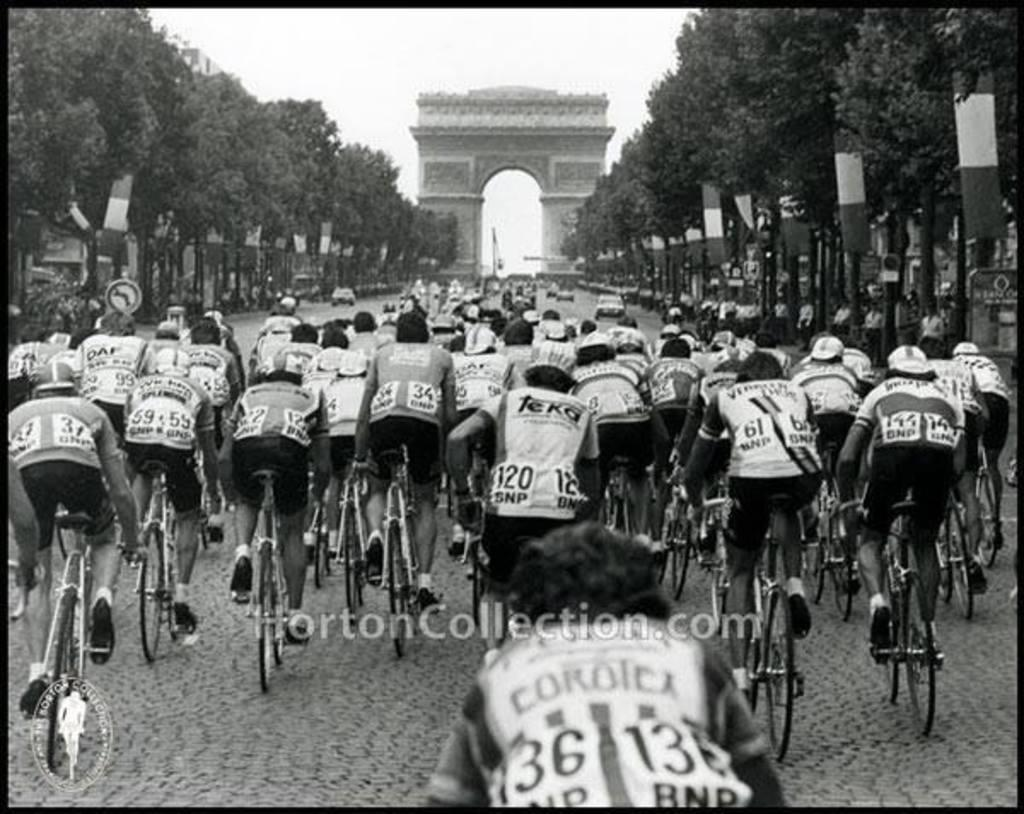What are the riders doing in the image? The riders are riding bicycles in the image. What can be seen on either side of the road in the image? There are trees on either side of the road in the image. What is in front of the riders in the image? There is an arch in front of the riders in the image. What type of toy can be seen in the hands of the riders in the image? There are no toys visible in the image; the riders are holding bicycle handles. 